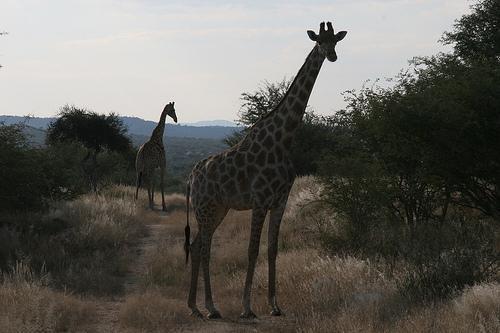How many giraffe are there?
Give a very brief answer. 2. 